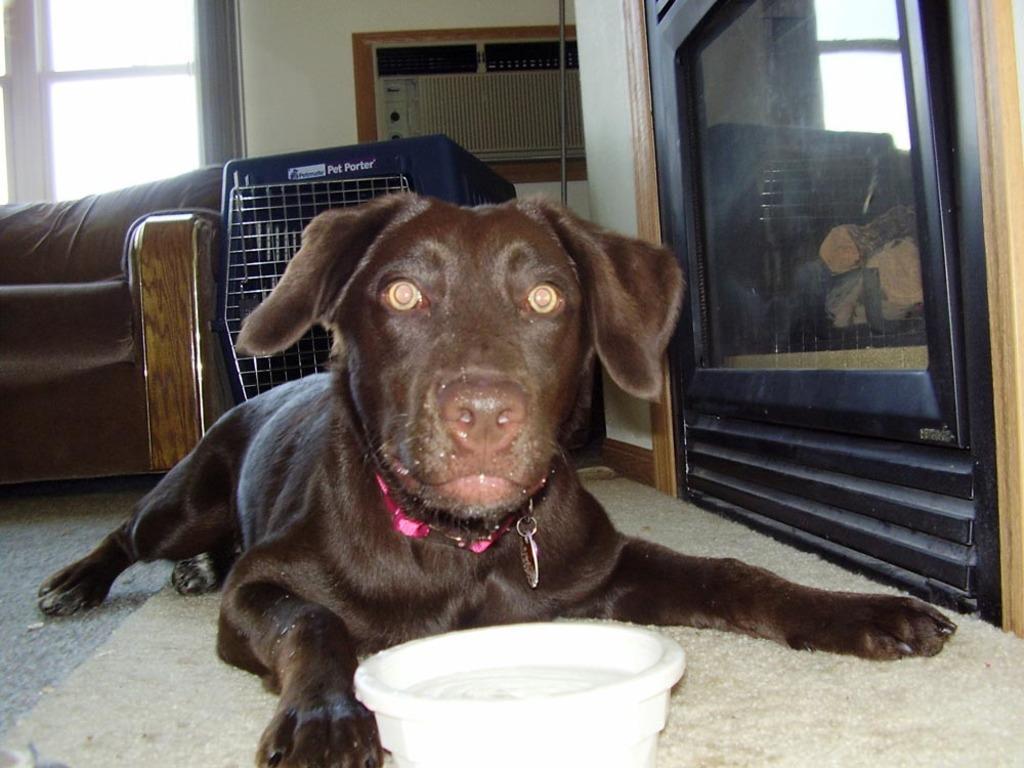Could you give a brief overview of what you see in this image? In this image, we can see a dog. We can also see a bowl. We can see the ground with a mat. We can see the sofa and an object. We can also see an object with some glass and some reflection is seen in it. We can also see a pole. 